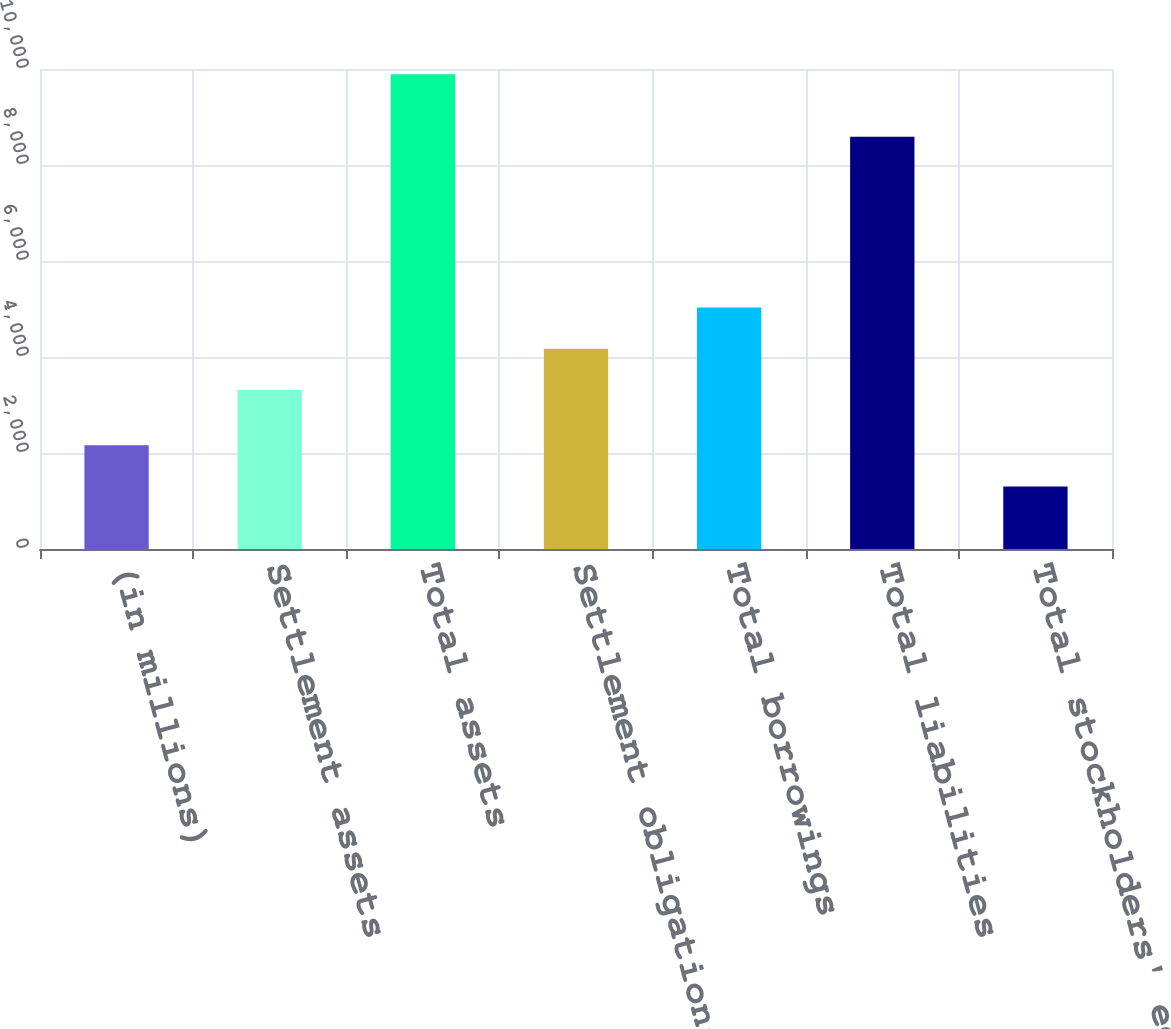Convert chart. <chart><loc_0><loc_0><loc_500><loc_500><bar_chart><fcel>(in millions)<fcel>Settlement assets<fcel>Total assets<fcel>Settlement obligations<fcel>Total borrowings<fcel>Total liabilities<fcel>Total stockholders' equity<nl><fcel>2159.4<fcel>3313.7<fcel>9890.4<fcel>4172.7<fcel>5031.7<fcel>8590<fcel>1300.4<nl></chart> 